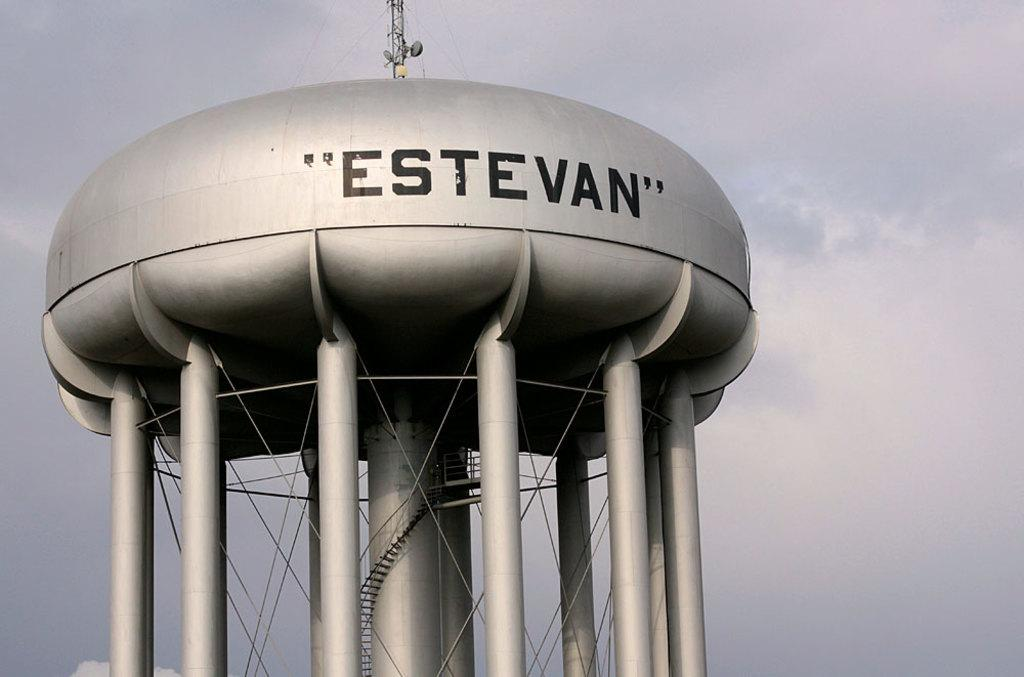<image>
Describe the image concisely. The grey water tower is called "Estevan" and has many legs. 